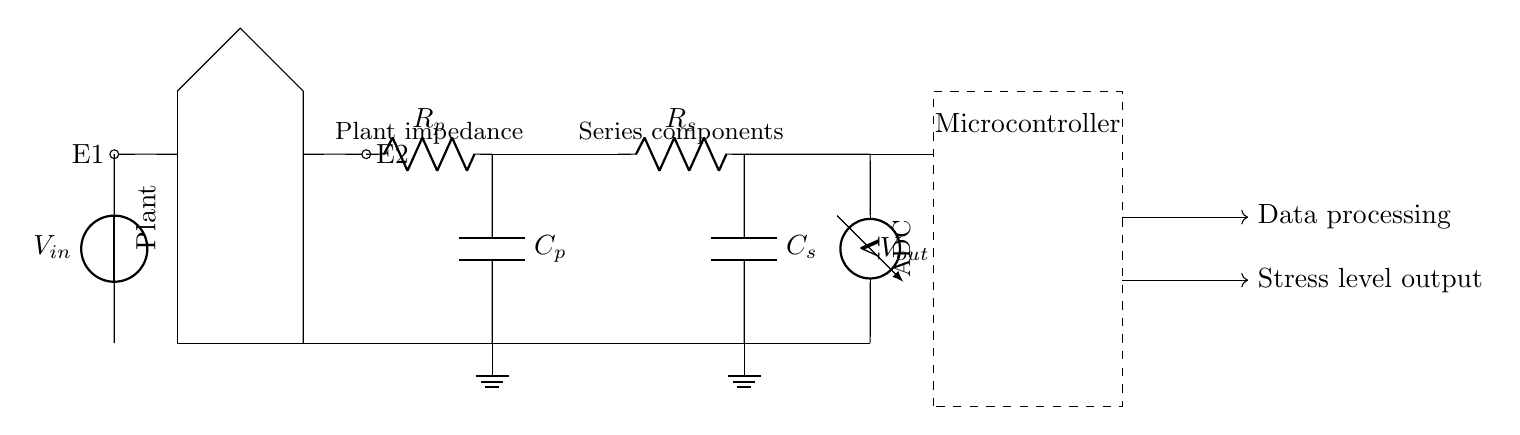What is the function of E1? E1 serves as one of the electrodes in the circuit that makes contact with the plant to measure its electrical impedance.
Answer: Electrode What components are in series with the plant impedance? The components in series with the plant impedance are the resistor R_s and the capacitor C_s.
Answer: R_s and C_s What does V_out represent in the circuit? V_out represents the output voltage measured across the series components, which indicates the plant's stress levels based on the impedance.
Answer: Output voltage How many resistors are present in the circuit? There are two resistors present: the plant resistor R_p and the series resistor R_s.
Answer: Two What is the purpose of the microcontroller? The microcontroller processes the data received from the voltage measurement and outputs the stress level of the plant.
Answer: Data processing What is the relation between plant stress level and impedance? Typically, an increase in stress level will correlate with changes in the plant's impedance, meaning higher impedance readings suggest higher stress.
Answer: Inverse relationship 